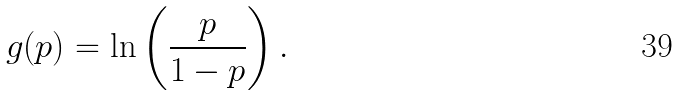<formula> <loc_0><loc_0><loc_500><loc_500>g ( p ) = \ln \left ( { \frac { p } { 1 - p } } \right ) .</formula> 